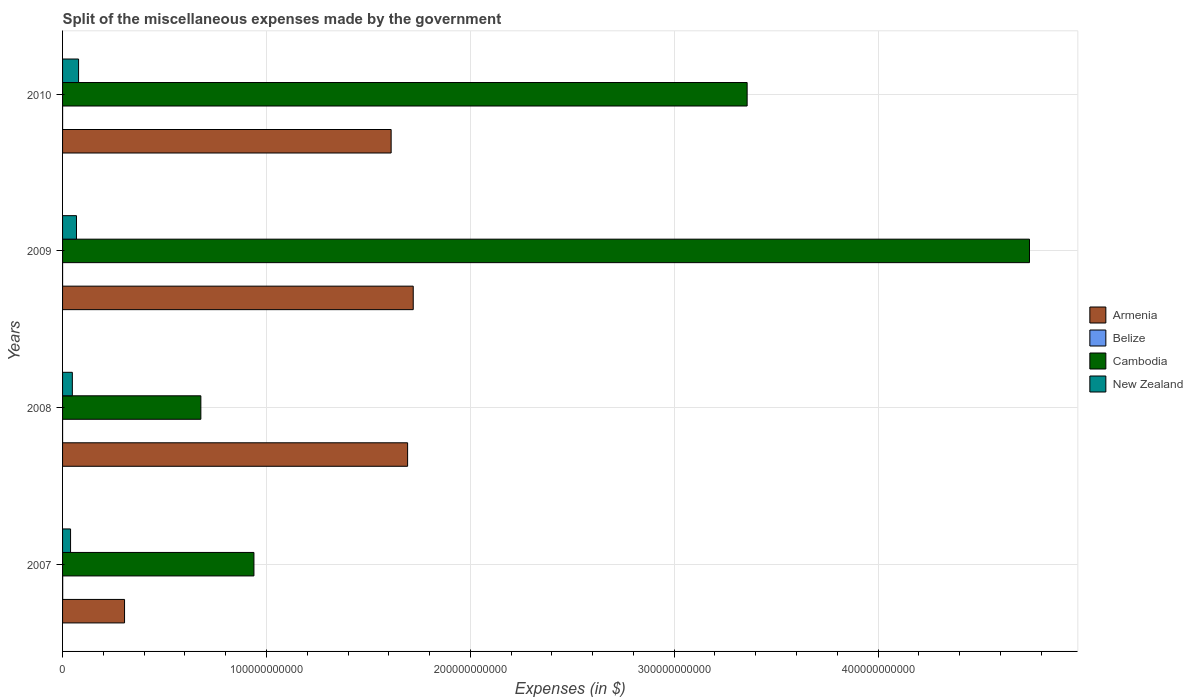How many different coloured bars are there?
Provide a short and direct response. 4. Are the number of bars per tick equal to the number of legend labels?
Make the answer very short. Yes. What is the label of the 4th group of bars from the top?
Ensure brevity in your answer.  2007. What is the miscellaneous expenses made by the government in Armenia in 2007?
Keep it short and to the point. 3.04e+1. Across all years, what is the maximum miscellaneous expenses made by the government in Cambodia?
Keep it short and to the point. 4.74e+11. Across all years, what is the minimum miscellaneous expenses made by the government in New Zealand?
Your response must be concise. 3.92e+09. In which year was the miscellaneous expenses made by the government in New Zealand maximum?
Your response must be concise. 2010. What is the total miscellaneous expenses made by the government in Armenia in the graph?
Give a very brief answer. 5.33e+11. What is the difference between the miscellaneous expenses made by the government in New Zealand in 2008 and that in 2009?
Keep it short and to the point. -2.04e+09. What is the difference between the miscellaneous expenses made by the government in Armenia in 2010 and the miscellaneous expenses made by the government in New Zealand in 2009?
Give a very brief answer. 1.54e+11. What is the average miscellaneous expenses made by the government in New Zealand per year?
Ensure brevity in your answer.  5.85e+09. In the year 2008, what is the difference between the miscellaneous expenses made by the government in Armenia and miscellaneous expenses made by the government in Cambodia?
Give a very brief answer. 1.01e+11. What is the ratio of the miscellaneous expenses made by the government in Armenia in 2007 to that in 2010?
Offer a very short reply. 0.19. Is the difference between the miscellaneous expenses made by the government in Armenia in 2008 and 2010 greater than the difference between the miscellaneous expenses made by the government in Cambodia in 2008 and 2010?
Your response must be concise. Yes. What is the difference between the highest and the second highest miscellaneous expenses made by the government in New Zealand?
Provide a succinct answer. 1.02e+09. What is the difference between the highest and the lowest miscellaneous expenses made by the government in Belize?
Give a very brief answer. 5.95e+07. In how many years, is the miscellaneous expenses made by the government in New Zealand greater than the average miscellaneous expenses made by the government in New Zealand taken over all years?
Offer a very short reply. 2. Is the sum of the miscellaneous expenses made by the government in Belize in 2007 and 2010 greater than the maximum miscellaneous expenses made by the government in New Zealand across all years?
Provide a short and direct response. No. Is it the case that in every year, the sum of the miscellaneous expenses made by the government in Armenia and miscellaneous expenses made by the government in Cambodia is greater than the sum of miscellaneous expenses made by the government in Belize and miscellaneous expenses made by the government in New Zealand?
Your answer should be very brief. No. What does the 2nd bar from the top in 2008 represents?
Provide a short and direct response. Cambodia. What does the 2nd bar from the bottom in 2010 represents?
Keep it short and to the point. Belize. How many bars are there?
Keep it short and to the point. 16. How many years are there in the graph?
Your answer should be compact. 4. What is the difference between two consecutive major ticks on the X-axis?
Your answer should be compact. 1.00e+11. Are the values on the major ticks of X-axis written in scientific E-notation?
Your answer should be very brief. No. Does the graph contain grids?
Offer a very short reply. Yes. Where does the legend appear in the graph?
Offer a very short reply. Center right. How are the legend labels stacked?
Keep it short and to the point. Vertical. What is the title of the graph?
Your answer should be very brief. Split of the miscellaneous expenses made by the government. Does "Curacao" appear as one of the legend labels in the graph?
Offer a terse response. No. What is the label or title of the X-axis?
Your response must be concise. Expenses (in $). What is the Expenses (in $) of Armenia in 2007?
Offer a terse response. 3.04e+1. What is the Expenses (in $) in Belize in 2007?
Ensure brevity in your answer.  6.27e+07. What is the Expenses (in $) of Cambodia in 2007?
Keep it short and to the point. 9.39e+1. What is the Expenses (in $) in New Zealand in 2007?
Ensure brevity in your answer.  3.92e+09. What is the Expenses (in $) of Armenia in 2008?
Your response must be concise. 1.69e+11. What is the Expenses (in $) of Belize in 2008?
Your response must be concise. 3.21e+06. What is the Expenses (in $) of Cambodia in 2008?
Offer a very short reply. 6.78e+1. What is the Expenses (in $) of New Zealand in 2008?
Your answer should be very brief. 4.79e+09. What is the Expenses (in $) of Armenia in 2009?
Offer a very short reply. 1.72e+11. What is the Expenses (in $) of Belize in 2009?
Keep it short and to the point. 4.39e+06. What is the Expenses (in $) of Cambodia in 2009?
Keep it short and to the point. 4.74e+11. What is the Expenses (in $) in New Zealand in 2009?
Give a very brief answer. 6.83e+09. What is the Expenses (in $) of Armenia in 2010?
Give a very brief answer. 1.61e+11. What is the Expenses (in $) in Belize in 2010?
Your response must be concise. 1.66e+07. What is the Expenses (in $) of Cambodia in 2010?
Make the answer very short. 3.36e+11. What is the Expenses (in $) in New Zealand in 2010?
Offer a very short reply. 7.85e+09. Across all years, what is the maximum Expenses (in $) in Armenia?
Make the answer very short. 1.72e+11. Across all years, what is the maximum Expenses (in $) in Belize?
Your response must be concise. 6.27e+07. Across all years, what is the maximum Expenses (in $) in Cambodia?
Provide a succinct answer. 4.74e+11. Across all years, what is the maximum Expenses (in $) in New Zealand?
Your answer should be very brief. 7.85e+09. Across all years, what is the minimum Expenses (in $) of Armenia?
Your answer should be very brief. 3.04e+1. Across all years, what is the minimum Expenses (in $) in Belize?
Give a very brief answer. 3.21e+06. Across all years, what is the minimum Expenses (in $) in Cambodia?
Keep it short and to the point. 6.78e+1. Across all years, what is the minimum Expenses (in $) in New Zealand?
Your answer should be very brief. 3.92e+09. What is the total Expenses (in $) in Armenia in the graph?
Make the answer very short. 5.33e+11. What is the total Expenses (in $) of Belize in the graph?
Give a very brief answer. 8.69e+07. What is the total Expenses (in $) of Cambodia in the graph?
Give a very brief answer. 9.72e+11. What is the total Expenses (in $) of New Zealand in the graph?
Your answer should be very brief. 2.34e+1. What is the difference between the Expenses (in $) of Armenia in 2007 and that in 2008?
Your answer should be very brief. -1.39e+11. What is the difference between the Expenses (in $) in Belize in 2007 and that in 2008?
Give a very brief answer. 5.95e+07. What is the difference between the Expenses (in $) in Cambodia in 2007 and that in 2008?
Provide a succinct answer. 2.60e+1. What is the difference between the Expenses (in $) of New Zealand in 2007 and that in 2008?
Make the answer very short. -8.73e+08. What is the difference between the Expenses (in $) of Armenia in 2007 and that in 2009?
Give a very brief answer. -1.42e+11. What is the difference between the Expenses (in $) of Belize in 2007 and that in 2009?
Make the answer very short. 5.83e+07. What is the difference between the Expenses (in $) in Cambodia in 2007 and that in 2009?
Offer a very short reply. -3.80e+11. What is the difference between the Expenses (in $) in New Zealand in 2007 and that in 2009?
Give a very brief answer. -2.91e+09. What is the difference between the Expenses (in $) in Armenia in 2007 and that in 2010?
Your response must be concise. -1.31e+11. What is the difference between the Expenses (in $) in Belize in 2007 and that in 2010?
Give a very brief answer. 4.62e+07. What is the difference between the Expenses (in $) in Cambodia in 2007 and that in 2010?
Make the answer very short. -2.42e+11. What is the difference between the Expenses (in $) of New Zealand in 2007 and that in 2010?
Your response must be concise. -3.93e+09. What is the difference between the Expenses (in $) of Armenia in 2008 and that in 2009?
Ensure brevity in your answer.  -2.76e+09. What is the difference between the Expenses (in $) in Belize in 2008 and that in 2009?
Offer a terse response. -1.19e+06. What is the difference between the Expenses (in $) in Cambodia in 2008 and that in 2009?
Offer a very short reply. -4.06e+11. What is the difference between the Expenses (in $) in New Zealand in 2008 and that in 2009?
Your answer should be very brief. -2.04e+09. What is the difference between the Expenses (in $) in Armenia in 2008 and that in 2010?
Make the answer very short. 8.07e+09. What is the difference between the Expenses (in $) in Belize in 2008 and that in 2010?
Provide a short and direct response. -1.33e+07. What is the difference between the Expenses (in $) in Cambodia in 2008 and that in 2010?
Your response must be concise. -2.68e+11. What is the difference between the Expenses (in $) in New Zealand in 2008 and that in 2010?
Your answer should be compact. -3.06e+09. What is the difference between the Expenses (in $) in Armenia in 2009 and that in 2010?
Make the answer very short. 1.08e+1. What is the difference between the Expenses (in $) in Belize in 2009 and that in 2010?
Your answer should be compact. -1.22e+07. What is the difference between the Expenses (in $) in Cambodia in 2009 and that in 2010?
Provide a short and direct response. 1.38e+11. What is the difference between the Expenses (in $) of New Zealand in 2009 and that in 2010?
Make the answer very short. -1.02e+09. What is the difference between the Expenses (in $) of Armenia in 2007 and the Expenses (in $) of Belize in 2008?
Provide a short and direct response. 3.04e+1. What is the difference between the Expenses (in $) of Armenia in 2007 and the Expenses (in $) of Cambodia in 2008?
Give a very brief answer. -3.74e+1. What is the difference between the Expenses (in $) in Armenia in 2007 and the Expenses (in $) in New Zealand in 2008?
Offer a terse response. 2.56e+1. What is the difference between the Expenses (in $) in Belize in 2007 and the Expenses (in $) in Cambodia in 2008?
Give a very brief answer. -6.78e+1. What is the difference between the Expenses (in $) of Belize in 2007 and the Expenses (in $) of New Zealand in 2008?
Ensure brevity in your answer.  -4.73e+09. What is the difference between the Expenses (in $) in Cambodia in 2007 and the Expenses (in $) in New Zealand in 2008?
Give a very brief answer. 8.91e+1. What is the difference between the Expenses (in $) of Armenia in 2007 and the Expenses (in $) of Belize in 2009?
Your answer should be compact. 3.04e+1. What is the difference between the Expenses (in $) of Armenia in 2007 and the Expenses (in $) of Cambodia in 2009?
Keep it short and to the point. -4.44e+11. What is the difference between the Expenses (in $) in Armenia in 2007 and the Expenses (in $) in New Zealand in 2009?
Give a very brief answer. 2.36e+1. What is the difference between the Expenses (in $) of Belize in 2007 and the Expenses (in $) of Cambodia in 2009?
Keep it short and to the point. -4.74e+11. What is the difference between the Expenses (in $) of Belize in 2007 and the Expenses (in $) of New Zealand in 2009?
Offer a terse response. -6.77e+09. What is the difference between the Expenses (in $) of Cambodia in 2007 and the Expenses (in $) of New Zealand in 2009?
Provide a short and direct response. 8.70e+1. What is the difference between the Expenses (in $) in Armenia in 2007 and the Expenses (in $) in Belize in 2010?
Your response must be concise. 3.04e+1. What is the difference between the Expenses (in $) of Armenia in 2007 and the Expenses (in $) of Cambodia in 2010?
Provide a succinct answer. -3.05e+11. What is the difference between the Expenses (in $) of Armenia in 2007 and the Expenses (in $) of New Zealand in 2010?
Offer a very short reply. 2.26e+1. What is the difference between the Expenses (in $) in Belize in 2007 and the Expenses (in $) in Cambodia in 2010?
Offer a very short reply. -3.36e+11. What is the difference between the Expenses (in $) in Belize in 2007 and the Expenses (in $) in New Zealand in 2010?
Your response must be concise. -7.79e+09. What is the difference between the Expenses (in $) in Cambodia in 2007 and the Expenses (in $) in New Zealand in 2010?
Provide a short and direct response. 8.60e+1. What is the difference between the Expenses (in $) of Armenia in 2008 and the Expenses (in $) of Belize in 2009?
Your answer should be very brief. 1.69e+11. What is the difference between the Expenses (in $) in Armenia in 2008 and the Expenses (in $) in Cambodia in 2009?
Your answer should be compact. -3.05e+11. What is the difference between the Expenses (in $) of Armenia in 2008 and the Expenses (in $) of New Zealand in 2009?
Give a very brief answer. 1.62e+11. What is the difference between the Expenses (in $) in Belize in 2008 and the Expenses (in $) in Cambodia in 2009?
Offer a terse response. -4.74e+11. What is the difference between the Expenses (in $) in Belize in 2008 and the Expenses (in $) in New Zealand in 2009?
Your answer should be very brief. -6.83e+09. What is the difference between the Expenses (in $) of Cambodia in 2008 and the Expenses (in $) of New Zealand in 2009?
Make the answer very short. 6.10e+1. What is the difference between the Expenses (in $) of Armenia in 2008 and the Expenses (in $) of Belize in 2010?
Your response must be concise. 1.69e+11. What is the difference between the Expenses (in $) in Armenia in 2008 and the Expenses (in $) in Cambodia in 2010?
Give a very brief answer. -1.67e+11. What is the difference between the Expenses (in $) in Armenia in 2008 and the Expenses (in $) in New Zealand in 2010?
Your answer should be compact. 1.61e+11. What is the difference between the Expenses (in $) of Belize in 2008 and the Expenses (in $) of Cambodia in 2010?
Your response must be concise. -3.36e+11. What is the difference between the Expenses (in $) of Belize in 2008 and the Expenses (in $) of New Zealand in 2010?
Your answer should be very brief. -7.85e+09. What is the difference between the Expenses (in $) in Cambodia in 2008 and the Expenses (in $) in New Zealand in 2010?
Provide a short and direct response. 6.00e+1. What is the difference between the Expenses (in $) of Armenia in 2009 and the Expenses (in $) of Belize in 2010?
Your answer should be very brief. 1.72e+11. What is the difference between the Expenses (in $) of Armenia in 2009 and the Expenses (in $) of Cambodia in 2010?
Ensure brevity in your answer.  -1.64e+11. What is the difference between the Expenses (in $) of Armenia in 2009 and the Expenses (in $) of New Zealand in 2010?
Your response must be concise. 1.64e+11. What is the difference between the Expenses (in $) in Belize in 2009 and the Expenses (in $) in Cambodia in 2010?
Offer a terse response. -3.36e+11. What is the difference between the Expenses (in $) of Belize in 2009 and the Expenses (in $) of New Zealand in 2010?
Provide a succinct answer. -7.85e+09. What is the difference between the Expenses (in $) of Cambodia in 2009 and the Expenses (in $) of New Zealand in 2010?
Provide a short and direct response. 4.66e+11. What is the average Expenses (in $) in Armenia per year?
Provide a short and direct response. 1.33e+11. What is the average Expenses (in $) of Belize per year?
Make the answer very short. 2.17e+07. What is the average Expenses (in $) in Cambodia per year?
Offer a terse response. 2.43e+11. What is the average Expenses (in $) in New Zealand per year?
Your answer should be very brief. 5.85e+09. In the year 2007, what is the difference between the Expenses (in $) of Armenia and Expenses (in $) of Belize?
Give a very brief answer. 3.03e+1. In the year 2007, what is the difference between the Expenses (in $) in Armenia and Expenses (in $) in Cambodia?
Give a very brief answer. -6.35e+1. In the year 2007, what is the difference between the Expenses (in $) in Armenia and Expenses (in $) in New Zealand?
Offer a very short reply. 2.65e+1. In the year 2007, what is the difference between the Expenses (in $) in Belize and Expenses (in $) in Cambodia?
Keep it short and to the point. -9.38e+1. In the year 2007, what is the difference between the Expenses (in $) of Belize and Expenses (in $) of New Zealand?
Your answer should be compact. -3.86e+09. In the year 2007, what is the difference between the Expenses (in $) of Cambodia and Expenses (in $) of New Zealand?
Ensure brevity in your answer.  8.99e+1. In the year 2008, what is the difference between the Expenses (in $) of Armenia and Expenses (in $) of Belize?
Provide a succinct answer. 1.69e+11. In the year 2008, what is the difference between the Expenses (in $) in Armenia and Expenses (in $) in Cambodia?
Keep it short and to the point. 1.01e+11. In the year 2008, what is the difference between the Expenses (in $) of Armenia and Expenses (in $) of New Zealand?
Keep it short and to the point. 1.64e+11. In the year 2008, what is the difference between the Expenses (in $) of Belize and Expenses (in $) of Cambodia?
Make the answer very short. -6.78e+1. In the year 2008, what is the difference between the Expenses (in $) in Belize and Expenses (in $) in New Zealand?
Provide a short and direct response. -4.79e+09. In the year 2008, what is the difference between the Expenses (in $) of Cambodia and Expenses (in $) of New Zealand?
Offer a terse response. 6.30e+1. In the year 2009, what is the difference between the Expenses (in $) in Armenia and Expenses (in $) in Belize?
Make the answer very short. 1.72e+11. In the year 2009, what is the difference between the Expenses (in $) in Armenia and Expenses (in $) in Cambodia?
Ensure brevity in your answer.  -3.02e+11. In the year 2009, what is the difference between the Expenses (in $) of Armenia and Expenses (in $) of New Zealand?
Make the answer very short. 1.65e+11. In the year 2009, what is the difference between the Expenses (in $) in Belize and Expenses (in $) in Cambodia?
Your answer should be compact. -4.74e+11. In the year 2009, what is the difference between the Expenses (in $) in Belize and Expenses (in $) in New Zealand?
Provide a succinct answer. -6.82e+09. In the year 2009, what is the difference between the Expenses (in $) of Cambodia and Expenses (in $) of New Zealand?
Ensure brevity in your answer.  4.67e+11. In the year 2010, what is the difference between the Expenses (in $) of Armenia and Expenses (in $) of Belize?
Provide a succinct answer. 1.61e+11. In the year 2010, what is the difference between the Expenses (in $) in Armenia and Expenses (in $) in Cambodia?
Provide a succinct answer. -1.75e+11. In the year 2010, what is the difference between the Expenses (in $) of Armenia and Expenses (in $) of New Zealand?
Provide a short and direct response. 1.53e+11. In the year 2010, what is the difference between the Expenses (in $) of Belize and Expenses (in $) of Cambodia?
Keep it short and to the point. -3.36e+11. In the year 2010, what is the difference between the Expenses (in $) of Belize and Expenses (in $) of New Zealand?
Your response must be concise. -7.84e+09. In the year 2010, what is the difference between the Expenses (in $) in Cambodia and Expenses (in $) in New Zealand?
Your answer should be compact. 3.28e+11. What is the ratio of the Expenses (in $) in Armenia in 2007 to that in 2008?
Your answer should be very brief. 0.18. What is the ratio of the Expenses (in $) of Belize in 2007 to that in 2008?
Give a very brief answer. 19.56. What is the ratio of the Expenses (in $) of Cambodia in 2007 to that in 2008?
Keep it short and to the point. 1.38. What is the ratio of the Expenses (in $) of New Zealand in 2007 to that in 2008?
Provide a succinct answer. 0.82. What is the ratio of the Expenses (in $) in Armenia in 2007 to that in 2009?
Your response must be concise. 0.18. What is the ratio of the Expenses (in $) of Belize in 2007 to that in 2009?
Offer a terse response. 14.28. What is the ratio of the Expenses (in $) of Cambodia in 2007 to that in 2009?
Provide a succinct answer. 0.2. What is the ratio of the Expenses (in $) of New Zealand in 2007 to that in 2009?
Your response must be concise. 0.57. What is the ratio of the Expenses (in $) of Armenia in 2007 to that in 2010?
Your answer should be very brief. 0.19. What is the ratio of the Expenses (in $) in Belize in 2007 to that in 2010?
Make the answer very short. 3.79. What is the ratio of the Expenses (in $) in Cambodia in 2007 to that in 2010?
Give a very brief answer. 0.28. What is the ratio of the Expenses (in $) of New Zealand in 2007 to that in 2010?
Offer a terse response. 0.5. What is the ratio of the Expenses (in $) in Armenia in 2008 to that in 2009?
Keep it short and to the point. 0.98. What is the ratio of the Expenses (in $) of Belize in 2008 to that in 2009?
Offer a terse response. 0.73. What is the ratio of the Expenses (in $) of Cambodia in 2008 to that in 2009?
Provide a succinct answer. 0.14. What is the ratio of the Expenses (in $) of New Zealand in 2008 to that in 2009?
Your answer should be very brief. 0.7. What is the ratio of the Expenses (in $) in Armenia in 2008 to that in 2010?
Keep it short and to the point. 1.05. What is the ratio of the Expenses (in $) of Belize in 2008 to that in 2010?
Provide a short and direct response. 0.19. What is the ratio of the Expenses (in $) in Cambodia in 2008 to that in 2010?
Ensure brevity in your answer.  0.2. What is the ratio of the Expenses (in $) of New Zealand in 2008 to that in 2010?
Keep it short and to the point. 0.61. What is the ratio of the Expenses (in $) of Armenia in 2009 to that in 2010?
Your answer should be compact. 1.07. What is the ratio of the Expenses (in $) in Belize in 2009 to that in 2010?
Your response must be concise. 0.27. What is the ratio of the Expenses (in $) of Cambodia in 2009 to that in 2010?
Give a very brief answer. 1.41. What is the ratio of the Expenses (in $) of New Zealand in 2009 to that in 2010?
Your response must be concise. 0.87. What is the difference between the highest and the second highest Expenses (in $) in Armenia?
Give a very brief answer. 2.76e+09. What is the difference between the highest and the second highest Expenses (in $) in Belize?
Offer a very short reply. 4.62e+07. What is the difference between the highest and the second highest Expenses (in $) in Cambodia?
Keep it short and to the point. 1.38e+11. What is the difference between the highest and the second highest Expenses (in $) of New Zealand?
Keep it short and to the point. 1.02e+09. What is the difference between the highest and the lowest Expenses (in $) of Armenia?
Your answer should be very brief. 1.42e+11. What is the difference between the highest and the lowest Expenses (in $) of Belize?
Your answer should be very brief. 5.95e+07. What is the difference between the highest and the lowest Expenses (in $) in Cambodia?
Give a very brief answer. 4.06e+11. What is the difference between the highest and the lowest Expenses (in $) in New Zealand?
Ensure brevity in your answer.  3.93e+09. 